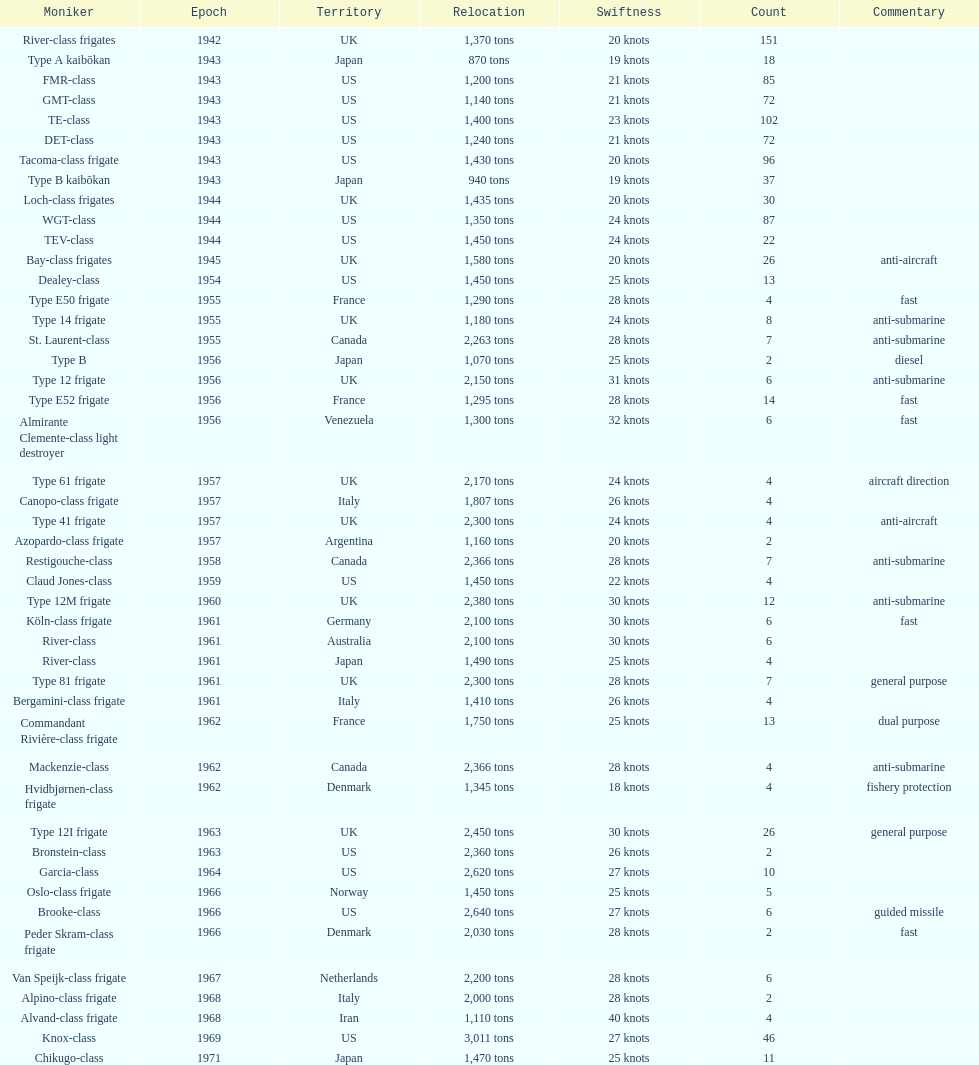What is the difference in speed for the gmt-class and the te-class? 2 knots. 